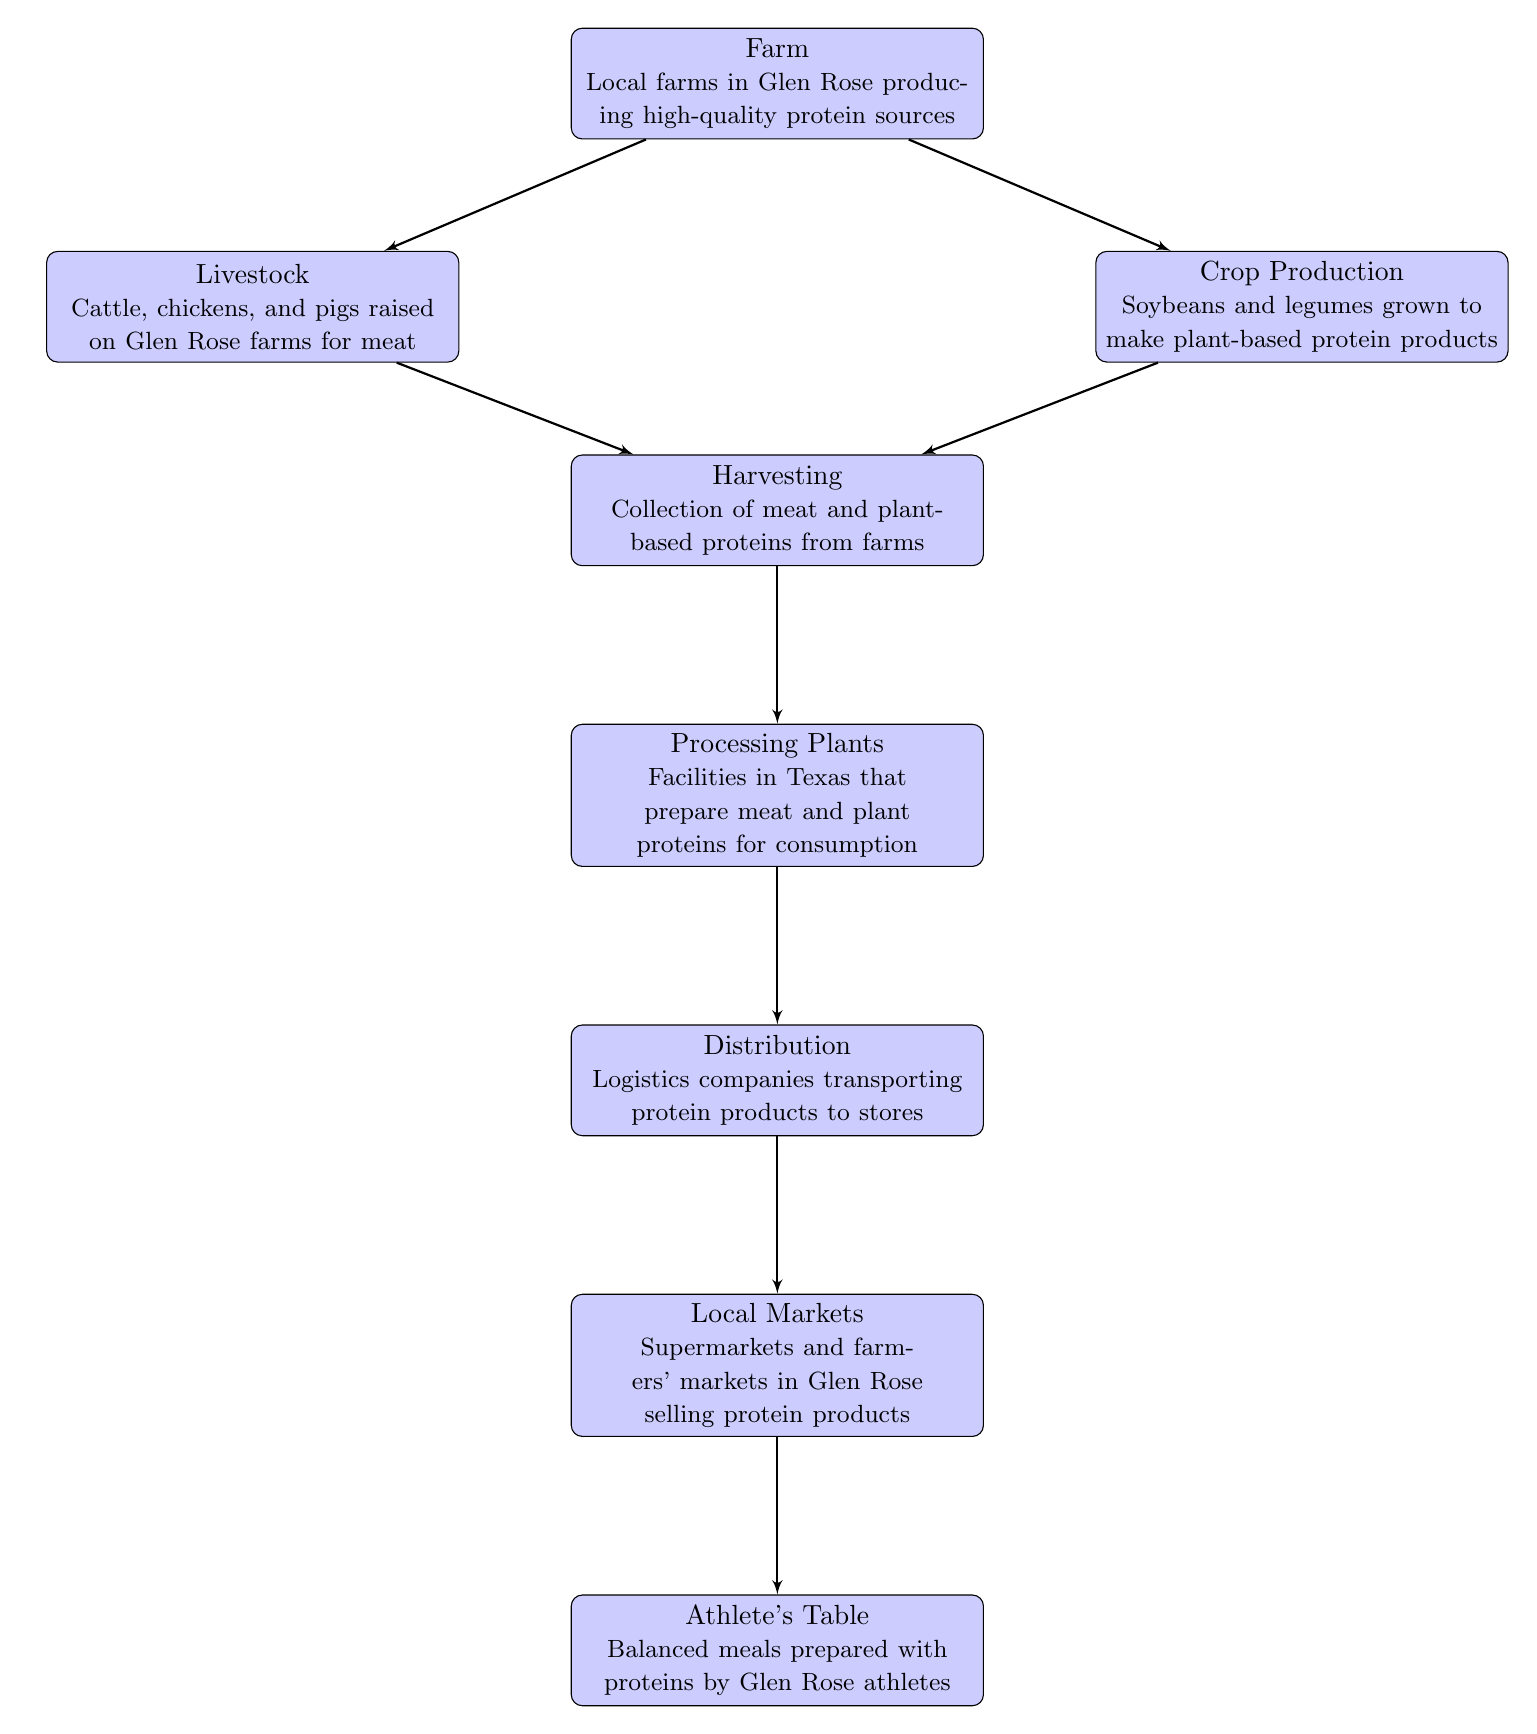What is the first step in the food chain? The first step in the food chain is represented by the node labeled "Farm," which indicates that local farms in Glen Rose produce high-quality protein sources.
Answer: Farm How many main protein source categories are listed in the diagram? There are two main categories of protein sources listed, which are livestock and crop production.
Answer: 2 Which node is located directly below "Harvesting"? The node located directly below "Harvesting" is "Processing Plants," indicating that after harvesting, the proteins are taken to facilities for preparation.
Answer: Processing Plants What protein sources are produced by livestock on Glen Rose farms? The diagram specifies that livestock includes cattle, chickens, and pigs which are raised for meat, indicating these are the protein sources from livestock.
Answer: Cattle, chickens, and pigs What is the end result of the food chain in the diagram? The end result of the food chain is "Athlete's Table," which represents balanced meals prepared with proteins for the athletes in Glen Rose.
Answer: Athlete's Table How is protein transported to local markets? The protein products are transported to local markets through the "Distribution" node, indicating that logistics companies handle the transportation.
Answer: Logistics companies transporting protein products What happens after the processing of proteins? After processing of proteins, the next step is "Distribution," where the protein products are transported to stores.
Answer: Distribution Which node represents the primary location where athletes acquire their meals? The node that represents the primary location where athletes acquire their meals is "Local Markets," which includes supermarkets and farmers' markets in Glen Rose.
Answer: Local Markets 